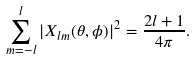Convert formula to latex. <formula><loc_0><loc_0><loc_500><loc_500>\sum _ { m = - l } ^ { l } | X _ { l m } ( \theta , \phi ) | ^ { 2 } = \frac { 2 l + 1 } { 4 \pi } .</formula> 